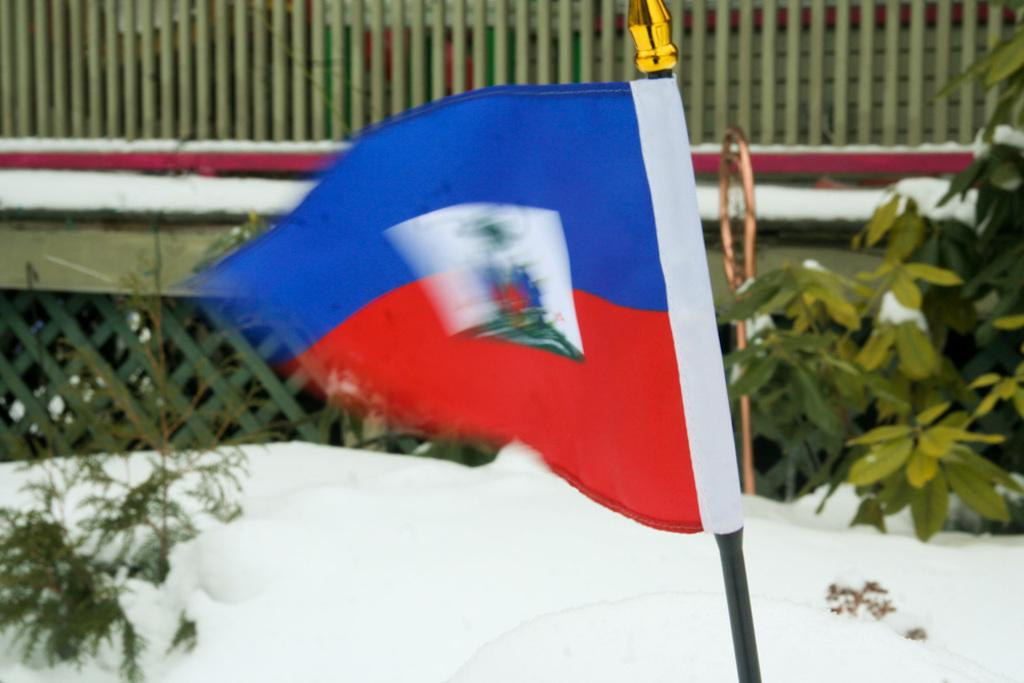What is the main subject in the center of the image? There is a flag in the center of the image. What is the surface beneath the flag? The flag is on a snow floor. What type of structure can be seen in the background of the image? There is a wooden house in the background of the image. What type of natural elements are present in the background of the image? Plants are present in the background of the image. What type of jam is being spread on the flag in the image? There is no jam present in the image, and the flag is not being used for spreading jam. 